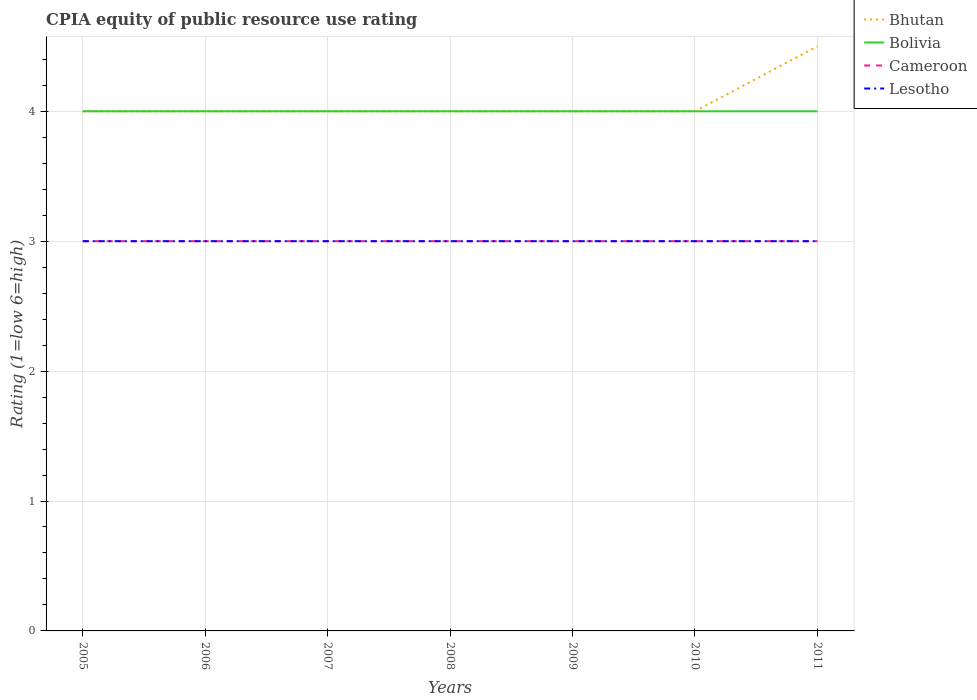Does the line corresponding to Bolivia intersect with the line corresponding to Bhutan?
Your answer should be compact. Yes. Across all years, what is the maximum CPIA rating in Bolivia?
Ensure brevity in your answer.  4. In which year was the CPIA rating in Bolivia maximum?
Offer a terse response. 2005. What is the total CPIA rating in Bhutan in the graph?
Give a very brief answer. -0.5. What is the difference between the highest and the second highest CPIA rating in Lesotho?
Your answer should be compact. 0. What is the difference between the highest and the lowest CPIA rating in Bhutan?
Your answer should be compact. 1. Are the values on the major ticks of Y-axis written in scientific E-notation?
Offer a very short reply. No. Does the graph contain any zero values?
Keep it short and to the point. No. Where does the legend appear in the graph?
Provide a succinct answer. Top right. How are the legend labels stacked?
Your response must be concise. Vertical. What is the title of the graph?
Your answer should be compact. CPIA equity of public resource use rating. Does "Togo" appear as one of the legend labels in the graph?
Offer a terse response. No. What is the label or title of the X-axis?
Give a very brief answer. Years. What is the label or title of the Y-axis?
Provide a short and direct response. Rating (1=low 6=high). What is the Rating (1=low 6=high) in Bhutan in 2005?
Provide a succinct answer. 4. What is the Rating (1=low 6=high) of Bolivia in 2005?
Give a very brief answer. 4. What is the Rating (1=low 6=high) in Cameroon in 2005?
Your answer should be very brief. 3. What is the Rating (1=low 6=high) in Bhutan in 2006?
Offer a very short reply. 4. What is the Rating (1=low 6=high) in Bolivia in 2006?
Ensure brevity in your answer.  4. What is the Rating (1=low 6=high) in Lesotho in 2006?
Offer a very short reply. 3. What is the Rating (1=low 6=high) of Bhutan in 2007?
Give a very brief answer. 4. What is the Rating (1=low 6=high) of Bolivia in 2007?
Offer a terse response. 4. What is the Rating (1=low 6=high) in Cameroon in 2008?
Your answer should be very brief. 3. What is the Rating (1=low 6=high) of Lesotho in 2008?
Keep it short and to the point. 3. What is the Rating (1=low 6=high) of Bhutan in 2009?
Give a very brief answer. 4. What is the Rating (1=low 6=high) in Bolivia in 2009?
Ensure brevity in your answer.  4. What is the Rating (1=low 6=high) of Lesotho in 2009?
Make the answer very short. 3. What is the Rating (1=low 6=high) of Bhutan in 2010?
Your answer should be very brief. 4. What is the Rating (1=low 6=high) of Lesotho in 2010?
Your answer should be compact. 3. Across all years, what is the maximum Rating (1=low 6=high) in Bolivia?
Provide a short and direct response. 4. Across all years, what is the maximum Rating (1=low 6=high) in Cameroon?
Provide a succinct answer. 3. Across all years, what is the maximum Rating (1=low 6=high) of Lesotho?
Provide a succinct answer. 3. Across all years, what is the minimum Rating (1=low 6=high) of Bolivia?
Make the answer very short. 4. Across all years, what is the minimum Rating (1=low 6=high) of Cameroon?
Your answer should be compact. 3. What is the total Rating (1=low 6=high) of Lesotho in the graph?
Your answer should be very brief. 21. What is the difference between the Rating (1=low 6=high) in Bolivia in 2005 and that in 2006?
Offer a terse response. 0. What is the difference between the Rating (1=low 6=high) of Cameroon in 2005 and that in 2006?
Your answer should be compact. 0. What is the difference between the Rating (1=low 6=high) in Lesotho in 2005 and that in 2006?
Ensure brevity in your answer.  0. What is the difference between the Rating (1=low 6=high) of Bolivia in 2005 and that in 2007?
Your response must be concise. 0. What is the difference between the Rating (1=low 6=high) in Cameroon in 2005 and that in 2007?
Make the answer very short. 0. What is the difference between the Rating (1=low 6=high) in Bhutan in 2005 and that in 2008?
Keep it short and to the point. 0. What is the difference between the Rating (1=low 6=high) in Bhutan in 2005 and that in 2009?
Provide a succinct answer. 0. What is the difference between the Rating (1=low 6=high) of Bhutan in 2005 and that in 2010?
Your response must be concise. 0. What is the difference between the Rating (1=low 6=high) of Bolivia in 2005 and that in 2010?
Provide a succinct answer. 0. What is the difference between the Rating (1=low 6=high) in Cameroon in 2005 and that in 2010?
Provide a succinct answer. 0. What is the difference between the Rating (1=low 6=high) of Bolivia in 2005 and that in 2011?
Keep it short and to the point. 0. What is the difference between the Rating (1=low 6=high) of Lesotho in 2005 and that in 2011?
Provide a succinct answer. 0. What is the difference between the Rating (1=low 6=high) of Cameroon in 2006 and that in 2007?
Your answer should be very brief. 0. What is the difference between the Rating (1=low 6=high) of Bhutan in 2006 and that in 2008?
Ensure brevity in your answer.  0. What is the difference between the Rating (1=low 6=high) of Bolivia in 2006 and that in 2008?
Provide a succinct answer. 0. What is the difference between the Rating (1=low 6=high) in Cameroon in 2006 and that in 2008?
Offer a terse response. 0. What is the difference between the Rating (1=low 6=high) of Lesotho in 2006 and that in 2008?
Keep it short and to the point. 0. What is the difference between the Rating (1=low 6=high) in Bhutan in 2006 and that in 2010?
Give a very brief answer. 0. What is the difference between the Rating (1=low 6=high) of Bolivia in 2006 and that in 2010?
Provide a short and direct response. 0. What is the difference between the Rating (1=low 6=high) of Bhutan in 2006 and that in 2011?
Offer a very short reply. -0.5. What is the difference between the Rating (1=low 6=high) in Bolivia in 2006 and that in 2011?
Offer a terse response. 0. What is the difference between the Rating (1=low 6=high) of Cameroon in 2006 and that in 2011?
Give a very brief answer. 0. What is the difference between the Rating (1=low 6=high) in Bolivia in 2007 and that in 2008?
Make the answer very short. 0. What is the difference between the Rating (1=low 6=high) of Cameroon in 2007 and that in 2008?
Offer a very short reply. 0. What is the difference between the Rating (1=low 6=high) of Bhutan in 2007 and that in 2009?
Make the answer very short. 0. What is the difference between the Rating (1=low 6=high) in Bolivia in 2007 and that in 2009?
Your response must be concise. 0. What is the difference between the Rating (1=low 6=high) in Cameroon in 2007 and that in 2009?
Offer a terse response. 0. What is the difference between the Rating (1=low 6=high) in Lesotho in 2007 and that in 2009?
Your answer should be compact. 0. What is the difference between the Rating (1=low 6=high) of Bhutan in 2007 and that in 2010?
Your response must be concise. 0. What is the difference between the Rating (1=low 6=high) of Bolivia in 2007 and that in 2010?
Your answer should be compact. 0. What is the difference between the Rating (1=low 6=high) in Lesotho in 2007 and that in 2010?
Your answer should be compact. 0. What is the difference between the Rating (1=low 6=high) of Bhutan in 2008 and that in 2009?
Your answer should be very brief. 0. What is the difference between the Rating (1=low 6=high) of Lesotho in 2008 and that in 2009?
Provide a succinct answer. 0. What is the difference between the Rating (1=low 6=high) in Bhutan in 2008 and that in 2010?
Offer a terse response. 0. What is the difference between the Rating (1=low 6=high) of Bolivia in 2008 and that in 2010?
Ensure brevity in your answer.  0. What is the difference between the Rating (1=low 6=high) of Cameroon in 2008 and that in 2010?
Offer a very short reply. 0. What is the difference between the Rating (1=low 6=high) of Cameroon in 2008 and that in 2011?
Offer a terse response. 0. What is the difference between the Rating (1=low 6=high) of Lesotho in 2008 and that in 2011?
Ensure brevity in your answer.  0. What is the difference between the Rating (1=low 6=high) in Bhutan in 2009 and that in 2010?
Make the answer very short. 0. What is the difference between the Rating (1=low 6=high) in Bolivia in 2009 and that in 2010?
Ensure brevity in your answer.  0. What is the difference between the Rating (1=low 6=high) of Lesotho in 2009 and that in 2010?
Keep it short and to the point. 0. What is the difference between the Rating (1=low 6=high) in Bolivia in 2009 and that in 2011?
Provide a succinct answer. 0. What is the difference between the Rating (1=low 6=high) in Lesotho in 2009 and that in 2011?
Provide a succinct answer. 0. What is the difference between the Rating (1=low 6=high) in Bhutan in 2010 and that in 2011?
Ensure brevity in your answer.  -0.5. What is the difference between the Rating (1=low 6=high) in Bolivia in 2010 and that in 2011?
Your answer should be very brief. 0. What is the difference between the Rating (1=low 6=high) of Cameroon in 2010 and that in 2011?
Keep it short and to the point. 0. What is the difference between the Rating (1=low 6=high) in Bhutan in 2005 and the Rating (1=low 6=high) in Lesotho in 2006?
Your answer should be compact. 1. What is the difference between the Rating (1=low 6=high) in Cameroon in 2005 and the Rating (1=low 6=high) in Lesotho in 2006?
Offer a terse response. 0. What is the difference between the Rating (1=low 6=high) in Bolivia in 2005 and the Rating (1=low 6=high) in Cameroon in 2007?
Provide a succinct answer. 1. What is the difference between the Rating (1=low 6=high) in Bolivia in 2005 and the Rating (1=low 6=high) in Lesotho in 2007?
Your answer should be very brief. 1. What is the difference between the Rating (1=low 6=high) in Cameroon in 2005 and the Rating (1=low 6=high) in Lesotho in 2007?
Offer a terse response. 0. What is the difference between the Rating (1=low 6=high) of Bhutan in 2005 and the Rating (1=low 6=high) of Bolivia in 2008?
Keep it short and to the point. 0. What is the difference between the Rating (1=low 6=high) in Bhutan in 2005 and the Rating (1=low 6=high) in Cameroon in 2008?
Offer a terse response. 1. What is the difference between the Rating (1=low 6=high) in Bhutan in 2005 and the Rating (1=low 6=high) in Lesotho in 2008?
Offer a very short reply. 1. What is the difference between the Rating (1=low 6=high) of Bolivia in 2005 and the Rating (1=low 6=high) of Lesotho in 2008?
Your answer should be very brief. 1. What is the difference between the Rating (1=low 6=high) of Bhutan in 2005 and the Rating (1=low 6=high) of Cameroon in 2009?
Provide a short and direct response. 1. What is the difference between the Rating (1=low 6=high) of Bhutan in 2005 and the Rating (1=low 6=high) of Lesotho in 2009?
Make the answer very short. 1. What is the difference between the Rating (1=low 6=high) in Cameroon in 2005 and the Rating (1=low 6=high) in Lesotho in 2009?
Give a very brief answer. 0. What is the difference between the Rating (1=low 6=high) in Bhutan in 2005 and the Rating (1=low 6=high) in Cameroon in 2010?
Provide a succinct answer. 1. What is the difference between the Rating (1=low 6=high) of Bhutan in 2005 and the Rating (1=low 6=high) of Lesotho in 2010?
Give a very brief answer. 1. What is the difference between the Rating (1=low 6=high) of Cameroon in 2005 and the Rating (1=low 6=high) of Lesotho in 2010?
Give a very brief answer. 0. What is the difference between the Rating (1=low 6=high) in Bolivia in 2005 and the Rating (1=low 6=high) in Cameroon in 2011?
Give a very brief answer. 1. What is the difference between the Rating (1=low 6=high) in Bolivia in 2005 and the Rating (1=low 6=high) in Lesotho in 2011?
Offer a terse response. 1. What is the difference between the Rating (1=low 6=high) of Bhutan in 2006 and the Rating (1=low 6=high) of Bolivia in 2007?
Give a very brief answer. 0. What is the difference between the Rating (1=low 6=high) of Bhutan in 2006 and the Rating (1=low 6=high) of Bolivia in 2008?
Keep it short and to the point. 0. What is the difference between the Rating (1=low 6=high) of Bhutan in 2006 and the Rating (1=low 6=high) of Cameroon in 2008?
Offer a terse response. 1. What is the difference between the Rating (1=low 6=high) in Bhutan in 2006 and the Rating (1=low 6=high) in Lesotho in 2008?
Give a very brief answer. 1. What is the difference between the Rating (1=low 6=high) of Bolivia in 2006 and the Rating (1=low 6=high) of Cameroon in 2008?
Make the answer very short. 1. What is the difference between the Rating (1=low 6=high) of Bolivia in 2006 and the Rating (1=low 6=high) of Lesotho in 2008?
Provide a short and direct response. 1. What is the difference between the Rating (1=low 6=high) of Cameroon in 2006 and the Rating (1=low 6=high) of Lesotho in 2008?
Keep it short and to the point. 0. What is the difference between the Rating (1=low 6=high) of Bolivia in 2006 and the Rating (1=low 6=high) of Cameroon in 2009?
Your response must be concise. 1. What is the difference between the Rating (1=low 6=high) of Bolivia in 2006 and the Rating (1=low 6=high) of Lesotho in 2009?
Ensure brevity in your answer.  1. What is the difference between the Rating (1=low 6=high) in Cameroon in 2006 and the Rating (1=low 6=high) in Lesotho in 2009?
Provide a succinct answer. 0. What is the difference between the Rating (1=low 6=high) in Bhutan in 2006 and the Rating (1=low 6=high) in Bolivia in 2010?
Give a very brief answer. 0. What is the difference between the Rating (1=low 6=high) in Bolivia in 2006 and the Rating (1=low 6=high) in Cameroon in 2010?
Make the answer very short. 1. What is the difference between the Rating (1=low 6=high) in Bhutan in 2006 and the Rating (1=low 6=high) in Bolivia in 2011?
Make the answer very short. 0. What is the difference between the Rating (1=low 6=high) in Bhutan in 2006 and the Rating (1=low 6=high) in Lesotho in 2011?
Give a very brief answer. 1. What is the difference between the Rating (1=low 6=high) of Bolivia in 2006 and the Rating (1=low 6=high) of Cameroon in 2011?
Your response must be concise. 1. What is the difference between the Rating (1=low 6=high) in Bolivia in 2006 and the Rating (1=low 6=high) in Lesotho in 2011?
Your response must be concise. 1. What is the difference between the Rating (1=low 6=high) of Cameroon in 2006 and the Rating (1=low 6=high) of Lesotho in 2011?
Offer a terse response. 0. What is the difference between the Rating (1=low 6=high) in Bhutan in 2007 and the Rating (1=low 6=high) in Bolivia in 2008?
Your response must be concise. 0. What is the difference between the Rating (1=low 6=high) of Bhutan in 2007 and the Rating (1=low 6=high) of Lesotho in 2008?
Your answer should be very brief. 1. What is the difference between the Rating (1=low 6=high) in Bolivia in 2007 and the Rating (1=low 6=high) in Cameroon in 2008?
Offer a very short reply. 1. What is the difference between the Rating (1=low 6=high) in Cameroon in 2007 and the Rating (1=low 6=high) in Lesotho in 2008?
Keep it short and to the point. 0. What is the difference between the Rating (1=low 6=high) of Bhutan in 2007 and the Rating (1=low 6=high) of Bolivia in 2009?
Your answer should be compact. 0. What is the difference between the Rating (1=low 6=high) in Bhutan in 2007 and the Rating (1=low 6=high) in Cameroon in 2009?
Your answer should be very brief. 1. What is the difference between the Rating (1=low 6=high) in Bolivia in 2007 and the Rating (1=low 6=high) in Cameroon in 2009?
Ensure brevity in your answer.  1. What is the difference between the Rating (1=low 6=high) in Bolivia in 2007 and the Rating (1=low 6=high) in Lesotho in 2009?
Make the answer very short. 1. What is the difference between the Rating (1=low 6=high) in Bhutan in 2007 and the Rating (1=low 6=high) in Bolivia in 2010?
Make the answer very short. 0. What is the difference between the Rating (1=low 6=high) of Bhutan in 2007 and the Rating (1=low 6=high) of Lesotho in 2010?
Provide a succinct answer. 1. What is the difference between the Rating (1=low 6=high) in Bolivia in 2007 and the Rating (1=low 6=high) in Lesotho in 2010?
Make the answer very short. 1. What is the difference between the Rating (1=low 6=high) in Cameroon in 2007 and the Rating (1=low 6=high) in Lesotho in 2010?
Provide a short and direct response. 0. What is the difference between the Rating (1=low 6=high) in Bhutan in 2007 and the Rating (1=low 6=high) in Cameroon in 2011?
Offer a very short reply. 1. What is the difference between the Rating (1=low 6=high) in Bhutan in 2007 and the Rating (1=low 6=high) in Lesotho in 2011?
Offer a very short reply. 1. What is the difference between the Rating (1=low 6=high) in Bhutan in 2008 and the Rating (1=low 6=high) in Bolivia in 2009?
Give a very brief answer. 0. What is the difference between the Rating (1=low 6=high) of Bhutan in 2008 and the Rating (1=low 6=high) of Cameroon in 2009?
Give a very brief answer. 1. What is the difference between the Rating (1=low 6=high) of Bhutan in 2008 and the Rating (1=low 6=high) of Lesotho in 2009?
Keep it short and to the point. 1. What is the difference between the Rating (1=low 6=high) in Bolivia in 2008 and the Rating (1=low 6=high) in Cameroon in 2009?
Give a very brief answer. 1. What is the difference between the Rating (1=low 6=high) of Bolivia in 2008 and the Rating (1=low 6=high) of Lesotho in 2009?
Provide a short and direct response. 1. What is the difference between the Rating (1=low 6=high) in Cameroon in 2008 and the Rating (1=low 6=high) in Lesotho in 2009?
Your answer should be compact. 0. What is the difference between the Rating (1=low 6=high) in Bhutan in 2008 and the Rating (1=low 6=high) in Cameroon in 2010?
Make the answer very short. 1. What is the difference between the Rating (1=low 6=high) in Cameroon in 2008 and the Rating (1=low 6=high) in Lesotho in 2010?
Offer a terse response. 0. What is the difference between the Rating (1=low 6=high) in Bhutan in 2008 and the Rating (1=low 6=high) in Bolivia in 2011?
Your answer should be very brief. 0. What is the difference between the Rating (1=low 6=high) in Bhutan in 2008 and the Rating (1=low 6=high) in Cameroon in 2011?
Keep it short and to the point. 1. What is the difference between the Rating (1=low 6=high) of Bhutan in 2008 and the Rating (1=low 6=high) of Lesotho in 2011?
Ensure brevity in your answer.  1. What is the difference between the Rating (1=low 6=high) of Bolivia in 2008 and the Rating (1=low 6=high) of Lesotho in 2011?
Provide a succinct answer. 1. What is the difference between the Rating (1=low 6=high) in Cameroon in 2008 and the Rating (1=low 6=high) in Lesotho in 2011?
Make the answer very short. 0. What is the difference between the Rating (1=low 6=high) of Bolivia in 2009 and the Rating (1=low 6=high) of Lesotho in 2010?
Keep it short and to the point. 1. What is the difference between the Rating (1=low 6=high) of Cameroon in 2009 and the Rating (1=low 6=high) of Lesotho in 2010?
Your answer should be very brief. 0. What is the difference between the Rating (1=low 6=high) of Bhutan in 2009 and the Rating (1=low 6=high) of Cameroon in 2011?
Provide a short and direct response. 1. What is the difference between the Rating (1=low 6=high) in Cameroon in 2009 and the Rating (1=low 6=high) in Lesotho in 2011?
Ensure brevity in your answer.  0. What is the difference between the Rating (1=low 6=high) in Bhutan in 2010 and the Rating (1=low 6=high) in Cameroon in 2011?
Your answer should be compact. 1. What is the difference between the Rating (1=low 6=high) in Bolivia in 2010 and the Rating (1=low 6=high) in Cameroon in 2011?
Your answer should be compact. 1. What is the difference between the Rating (1=low 6=high) in Cameroon in 2010 and the Rating (1=low 6=high) in Lesotho in 2011?
Your response must be concise. 0. What is the average Rating (1=low 6=high) of Bhutan per year?
Your response must be concise. 4.07. What is the average Rating (1=low 6=high) of Cameroon per year?
Offer a very short reply. 3. What is the average Rating (1=low 6=high) of Lesotho per year?
Provide a short and direct response. 3. In the year 2005, what is the difference between the Rating (1=low 6=high) of Bhutan and Rating (1=low 6=high) of Cameroon?
Offer a very short reply. 1. In the year 2005, what is the difference between the Rating (1=low 6=high) in Bhutan and Rating (1=low 6=high) in Lesotho?
Give a very brief answer. 1. In the year 2005, what is the difference between the Rating (1=low 6=high) in Cameroon and Rating (1=low 6=high) in Lesotho?
Offer a terse response. 0. In the year 2006, what is the difference between the Rating (1=low 6=high) of Bhutan and Rating (1=low 6=high) of Bolivia?
Your answer should be compact. 0. In the year 2006, what is the difference between the Rating (1=low 6=high) in Bhutan and Rating (1=low 6=high) in Cameroon?
Provide a short and direct response. 1. In the year 2006, what is the difference between the Rating (1=low 6=high) of Bhutan and Rating (1=low 6=high) of Lesotho?
Your answer should be compact. 1. In the year 2006, what is the difference between the Rating (1=low 6=high) in Bolivia and Rating (1=low 6=high) in Cameroon?
Your response must be concise. 1. In the year 2007, what is the difference between the Rating (1=low 6=high) in Bhutan and Rating (1=low 6=high) in Bolivia?
Provide a short and direct response. 0. In the year 2007, what is the difference between the Rating (1=low 6=high) in Bhutan and Rating (1=low 6=high) in Cameroon?
Provide a succinct answer. 1. In the year 2007, what is the difference between the Rating (1=low 6=high) in Bhutan and Rating (1=low 6=high) in Lesotho?
Your answer should be very brief. 1. In the year 2007, what is the difference between the Rating (1=low 6=high) in Bolivia and Rating (1=low 6=high) in Cameroon?
Your answer should be very brief. 1. In the year 2008, what is the difference between the Rating (1=low 6=high) of Bhutan and Rating (1=low 6=high) of Bolivia?
Your response must be concise. 0. In the year 2008, what is the difference between the Rating (1=low 6=high) in Bhutan and Rating (1=low 6=high) in Cameroon?
Offer a terse response. 1. In the year 2008, what is the difference between the Rating (1=low 6=high) of Bolivia and Rating (1=low 6=high) of Lesotho?
Offer a terse response. 1. In the year 2008, what is the difference between the Rating (1=low 6=high) in Cameroon and Rating (1=low 6=high) in Lesotho?
Provide a short and direct response. 0. In the year 2009, what is the difference between the Rating (1=low 6=high) in Bhutan and Rating (1=low 6=high) in Cameroon?
Make the answer very short. 1. In the year 2009, what is the difference between the Rating (1=low 6=high) in Bhutan and Rating (1=low 6=high) in Lesotho?
Offer a terse response. 1. In the year 2009, what is the difference between the Rating (1=low 6=high) in Bolivia and Rating (1=low 6=high) in Cameroon?
Provide a succinct answer. 1. In the year 2009, what is the difference between the Rating (1=low 6=high) in Cameroon and Rating (1=low 6=high) in Lesotho?
Give a very brief answer. 0. In the year 2010, what is the difference between the Rating (1=low 6=high) of Bhutan and Rating (1=low 6=high) of Lesotho?
Your response must be concise. 1. In the year 2010, what is the difference between the Rating (1=low 6=high) in Cameroon and Rating (1=low 6=high) in Lesotho?
Your answer should be very brief. 0. In the year 2011, what is the difference between the Rating (1=low 6=high) in Bhutan and Rating (1=low 6=high) in Lesotho?
Give a very brief answer. 1.5. In the year 2011, what is the difference between the Rating (1=low 6=high) in Bolivia and Rating (1=low 6=high) in Cameroon?
Your answer should be very brief. 1. In the year 2011, what is the difference between the Rating (1=low 6=high) of Cameroon and Rating (1=low 6=high) of Lesotho?
Your answer should be very brief. 0. What is the ratio of the Rating (1=low 6=high) in Bhutan in 2005 to that in 2006?
Provide a succinct answer. 1. What is the ratio of the Rating (1=low 6=high) in Bolivia in 2005 to that in 2006?
Offer a very short reply. 1. What is the ratio of the Rating (1=low 6=high) in Cameroon in 2005 to that in 2006?
Your answer should be very brief. 1. What is the ratio of the Rating (1=low 6=high) of Bhutan in 2005 to that in 2007?
Provide a succinct answer. 1. What is the ratio of the Rating (1=low 6=high) in Cameroon in 2005 to that in 2007?
Give a very brief answer. 1. What is the ratio of the Rating (1=low 6=high) in Bhutan in 2005 to that in 2008?
Make the answer very short. 1. What is the ratio of the Rating (1=low 6=high) of Bolivia in 2005 to that in 2008?
Keep it short and to the point. 1. What is the ratio of the Rating (1=low 6=high) in Bolivia in 2005 to that in 2009?
Give a very brief answer. 1. What is the ratio of the Rating (1=low 6=high) in Lesotho in 2005 to that in 2009?
Your answer should be compact. 1. What is the ratio of the Rating (1=low 6=high) in Bhutan in 2005 to that in 2010?
Make the answer very short. 1. What is the ratio of the Rating (1=low 6=high) of Cameroon in 2005 to that in 2010?
Offer a very short reply. 1. What is the ratio of the Rating (1=low 6=high) of Lesotho in 2005 to that in 2010?
Offer a terse response. 1. What is the ratio of the Rating (1=low 6=high) of Bolivia in 2005 to that in 2011?
Make the answer very short. 1. What is the ratio of the Rating (1=low 6=high) of Cameroon in 2005 to that in 2011?
Your response must be concise. 1. What is the ratio of the Rating (1=low 6=high) of Lesotho in 2005 to that in 2011?
Ensure brevity in your answer.  1. What is the ratio of the Rating (1=low 6=high) of Bhutan in 2006 to that in 2007?
Make the answer very short. 1. What is the ratio of the Rating (1=low 6=high) in Bolivia in 2006 to that in 2008?
Ensure brevity in your answer.  1. What is the ratio of the Rating (1=low 6=high) in Bhutan in 2006 to that in 2009?
Provide a short and direct response. 1. What is the ratio of the Rating (1=low 6=high) of Cameroon in 2006 to that in 2009?
Offer a terse response. 1. What is the ratio of the Rating (1=low 6=high) of Bhutan in 2006 to that in 2010?
Provide a succinct answer. 1. What is the ratio of the Rating (1=low 6=high) in Bolivia in 2006 to that in 2010?
Offer a terse response. 1. What is the ratio of the Rating (1=low 6=high) of Cameroon in 2006 to that in 2010?
Your response must be concise. 1. What is the ratio of the Rating (1=low 6=high) of Lesotho in 2006 to that in 2010?
Offer a terse response. 1. What is the ratio of the Rating (1=low 6=high) of Lesotho in 2006 to that in 2011?
Offer a terse response. 1. What is the ratio of the Rating (1=low 6=high) in Bhutan in 2007 to that in 2008?
Ensure brevity in your answer.  1. What is the ratio of the Rating (1=low 6=high) in Lesotho in 2007 to that in 2008?
Provide a succinct answer. 1. What is the ratio of the Rating (1=low 6=high) in Lesotho in 2007 to that in 2009?
Keep it short and to the point. 1. What is the ratio of the Rating (1=low 6=high) of Bolivia in 2007 to that in 2010?
Keep it short and to the point. 1. What is the ratio of the Rating (1=low 6=high) in Cameroon in 2007 to that in 2010?
Provide a short and direct response. 1. What is the ratio of the Rating (1=low 6=high) of Lesotho in 2007 to that in 2010?
Your answer should be compact. 1. What is the ratio of the Rating (1=low 6=high) in Bhutan in 2007 to that in 2011?
Provide a short and direct response. 0.89. What is the ratio of the Rating (1=low 6=high) of Bolivia in 2007 to that in 2011?
Offer a terse response. 1. What is the ratio of the Rating (1=low 6=high) in Cameroon in 2007 to that in 2011?
Your response must be concise. 1. What is the ratio of the Rating (1=low 6=high) of Cameroon in 2008 to that in 2010?
Give a very brief answer. 1. What is the ratio of the Rating (1=low 6=high) of Lesotho in 2008 to that in 2010?
Offer a terse response. 1. What is the ratio of the Rating (1=low 6=high) in Bhutan in 2009 to that in 2010?
Provide a short and direct response. 1. What is the ratio of the Rating (1=low 6=high) in Cameroon in 2009 to that in 2010?
Make the answer very short. 1. What is the ratio of the Rating (1=low 6=high) of Bhutan in 2009 to that in 2011?
Give a very brief answer. 0.89. What is the ratio of the Rating (1=low 6=high) of Bolivia in 2009 to that in 2011?
Offer a very short reply. 1. What is the ratio of the Rating (1=low 6=high) in Cameroon in 2009 to that in 2011?
Make the answer very short. 1. What is the ratio of the Rating (1=low 6=high) of Bhutan in 2010 to that in 2011?
Ensure brevity in your answer.  0.89. What is the ratio of the Rating (1=low 6=high) in Lesotho in 2010 to that in 2011?
Provide a short and direct response. 1. What is the difference between the highest and the lowest Rating (1=low 6=high) of Cameroon?
Your answer should be compact. 0. What is the difference between the highest and the lowest Rating (1=low 6=high) of Lesotho?
Make the answer very short. 0. 